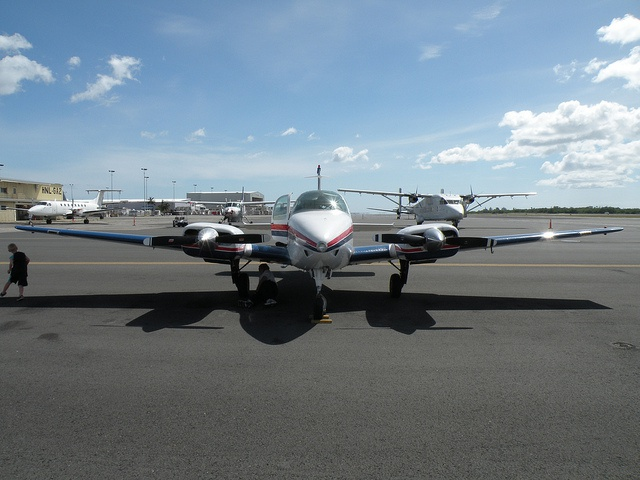Describe the objects in this image and their specific colors. I can see airplane in gray, black, lightgray, and darkgray tones, airplane in gray, lightgray, darkgray, and lightblue tones, airplane in gray, lightgray, darkgray, and black tones, people in gray, black, and purple tones, and people in black and gray tones in this image. 